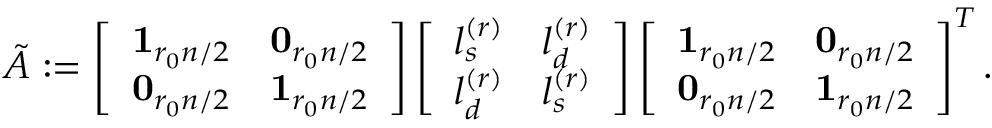Convert formula to latex. <formula><loc_0><loc_0><loc_500><loc_500>\begin{array} { r } { \tilde { A } \colon = \left [ \begin{array} { l l } { 1 _ { r _ { 0 } n / 2 } } & { 0 _ { r _ { 0 } n / 2 } } \\ { 0 _ { r _ { 0 } n / 2 } } & { 1 _ { r _ { 0 } n / 2 } } \end{array} \right ] \left [ \begin{array} { l l } { l _ { s } ^ { ( r ) } } & { l _ { d } ^ { ( r ) } } \\ { l _ { d } ^ { ( r ) } } & { l _ { s } ^ { ( r ) } } \end{array} \right ] \left [ \begin{array} { l l } { 1 _ { r _ { 0 } n / 2 } } & { 0 _ { r _ { 0 } n / 2 } } \\ { 0 _ { r _ { 0 } n / 2 } } & { 1 _ { r _ { 0 } n / 2 } } \end{array} \right ] ^ { T } . } \end{array}</formula> 